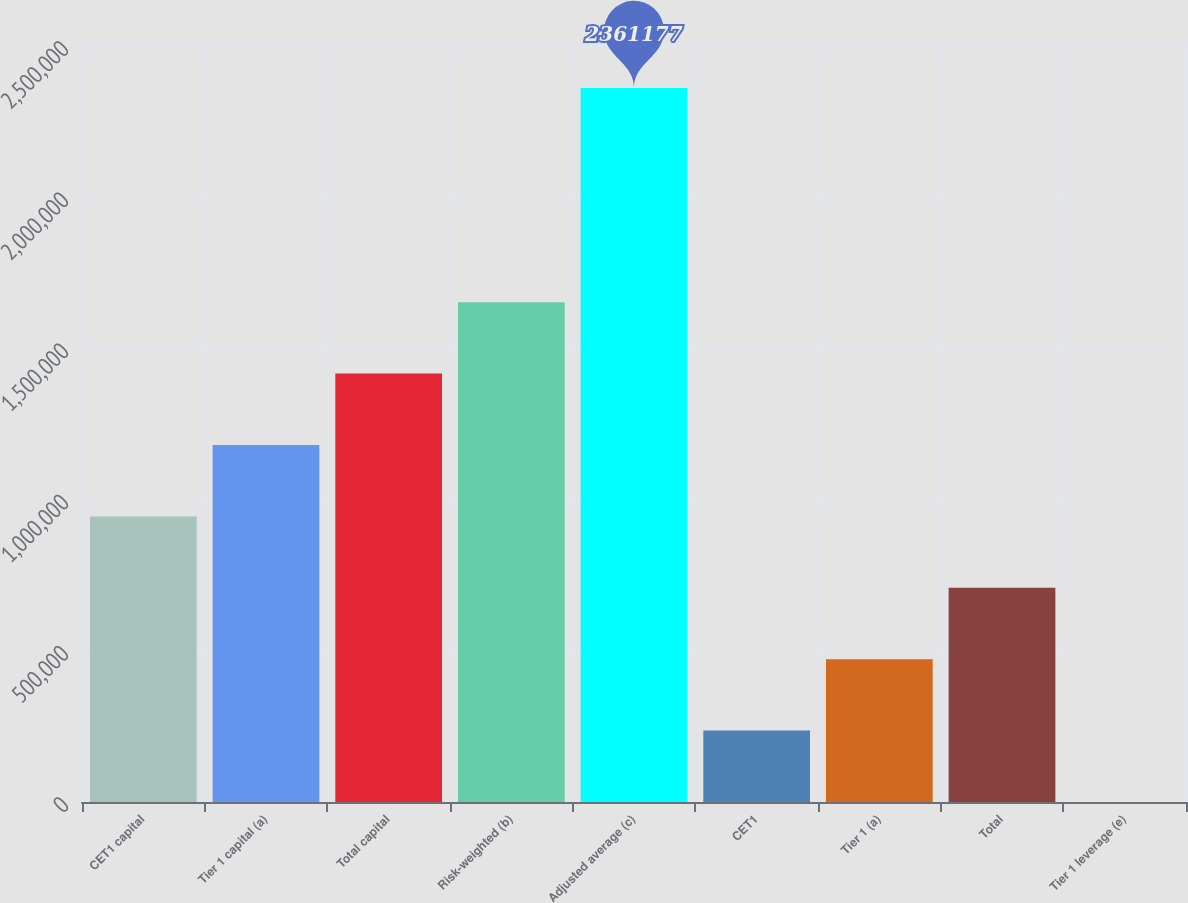<chart> <loc_0><loc_0><loc_500><loc_500><bar_chart><fcel>CET1 capital<fcel>Tier 1 capital (a)<fcel>Total capital<fcel>Risk-weighted (b)<fcel>Adjusted average (c)<fcel>CET1<fcel>Tier 1 (a)<fcel>Total<fcel>Tier 1 leverage (e)<nl><fcel>944476<fcel>1.18059e+06<fcel>1.41671e+06<fcel>1.65283e+06<fcel>2.36118e+06<fcel>236125<fcel>472242<fcel>708359<fcel>8.5<nl></chart> 